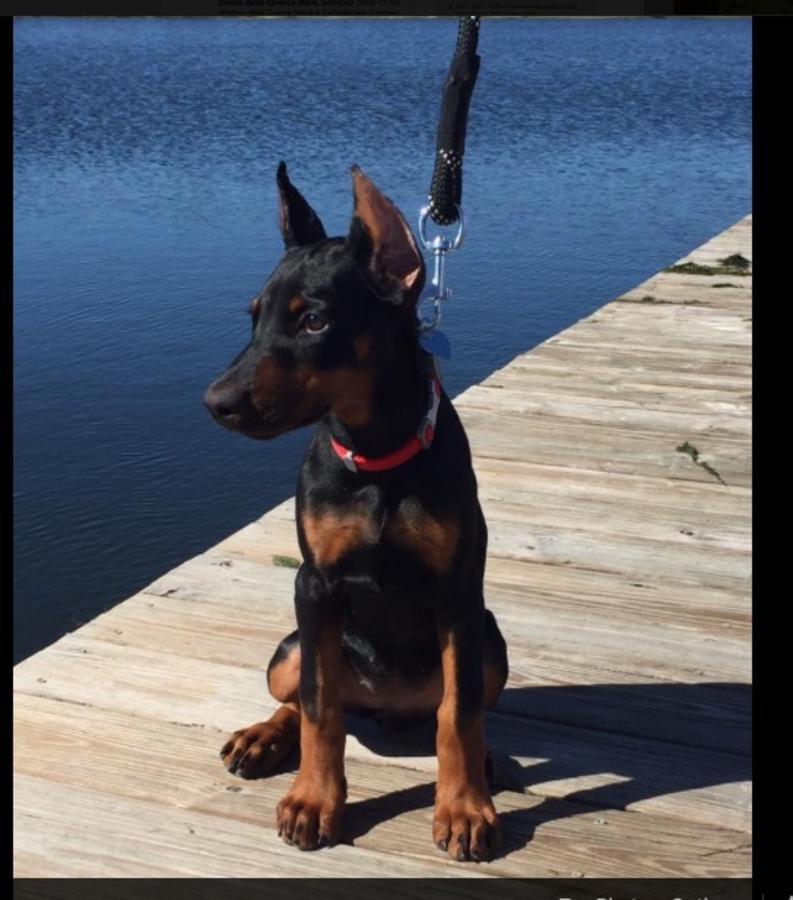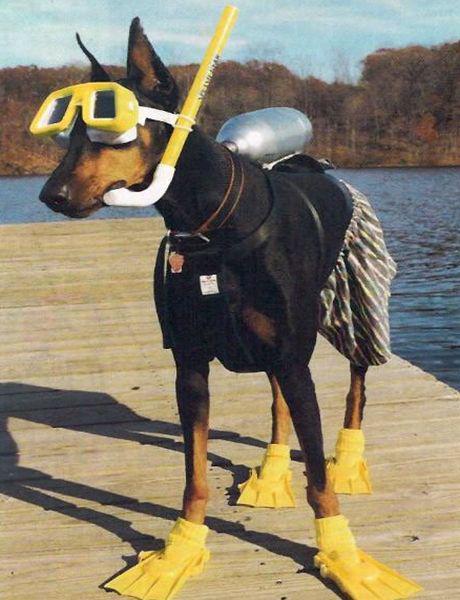The first image is the image on the left, the second image is the image on the right. For the images shown, is this caption "In one of the images, the dogs are wearing things on their paws." true? Answer yes or no. Yes. The first image is the image on the left, the second image is the image on the right. Considering the images on both sides, is "In one of the images, a doberman is holding an object in its mouth." valid? Answer yes or no. Yes. 